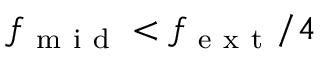Convert formula to latex. <formula><loc_0><loc_0><loc_500><loc_500>f _ { m i d } < f _ { e x t } / 4</formula> 